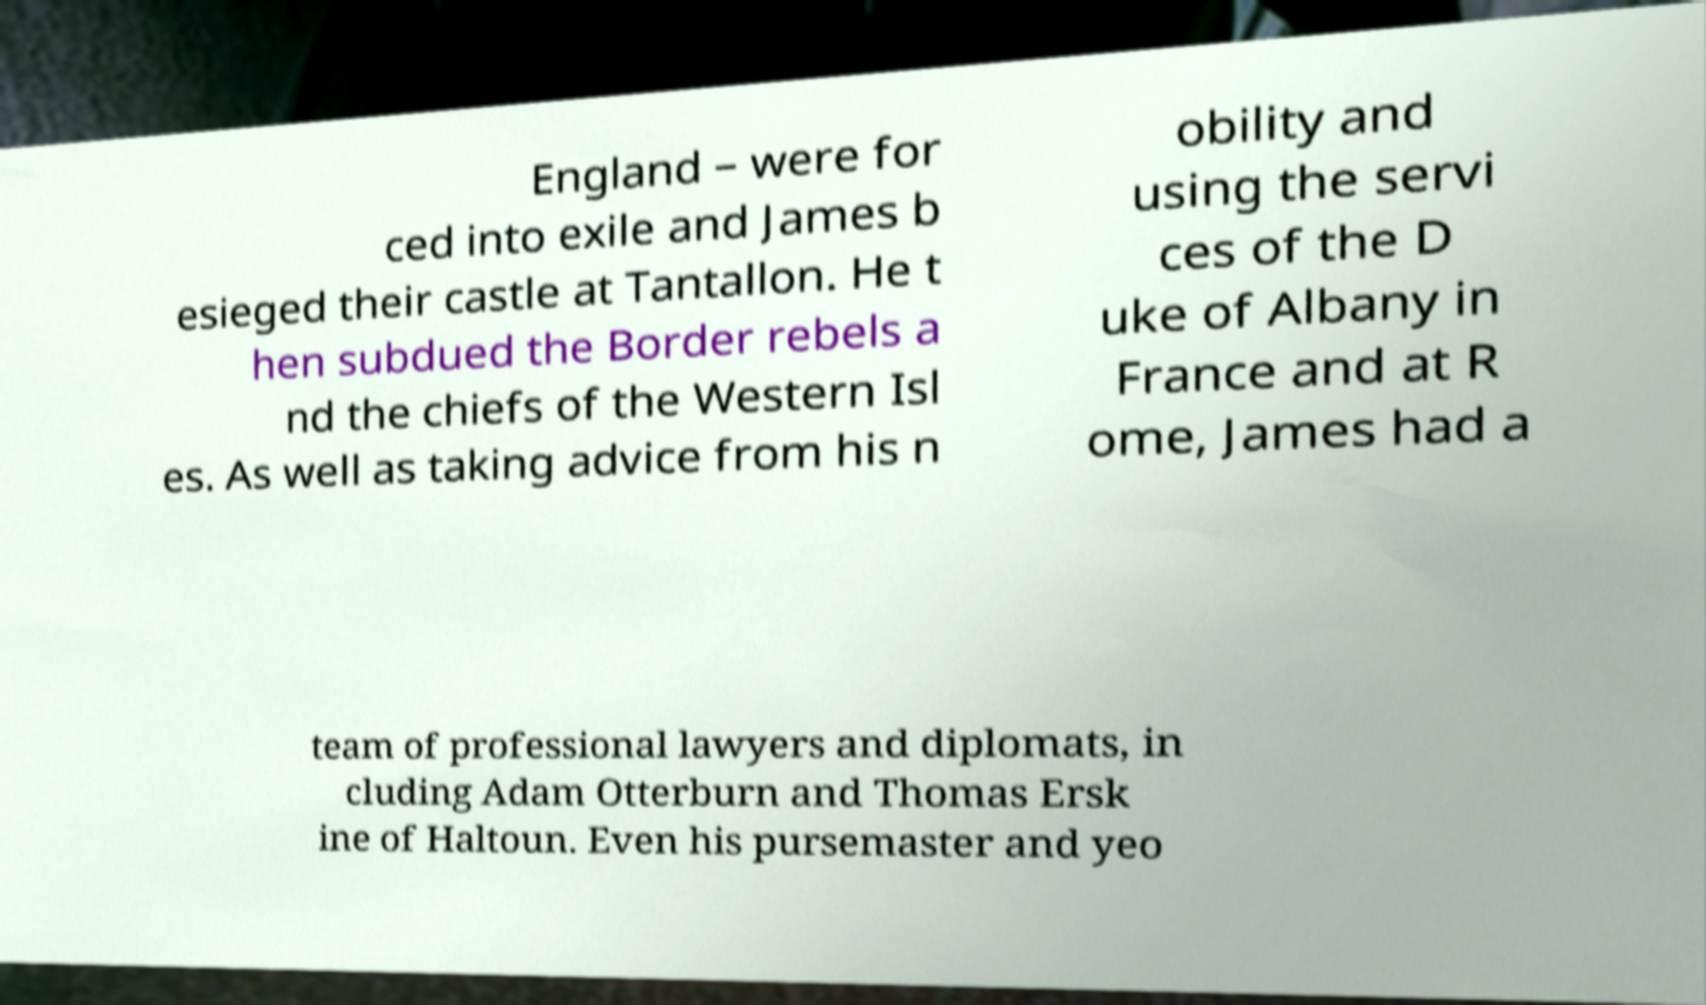Please identify and transcribe the text found in this image. England – were for ced into exile and James b esieged their castle at Tantallon. He t hen subdued the Border rebels a nd the chiefs of the Western Isl es. As well as taking advice from his n obility and using the servi ces of the D uke of Albany in France and at R ome, James had a team of professional lawyers and diplomats, in cluding Adam Otterburn and Thomas Ersk ine of Haltoun. Even his pursemaster and yeo 